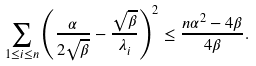Convert formula to latex. <formula><loc_0><loc_0><loc_500><loc_500>\sum _ { 1 \leq i \leq n } \left ( \frac { \alpha } { 2 \sqrt { \beta } } - \frac { \sqrt { \beta } } { \lambda _ { i } } \right ) ^ { 2 } \leq \frac { n \alpha ^ { 2 } - 4 \beta } { 4 \beta } .</formula> 